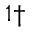Convert formula to latex. <formula><loc_0><loc_0><loc_500><loc_500>^ { 1 \dagger }</formula> 